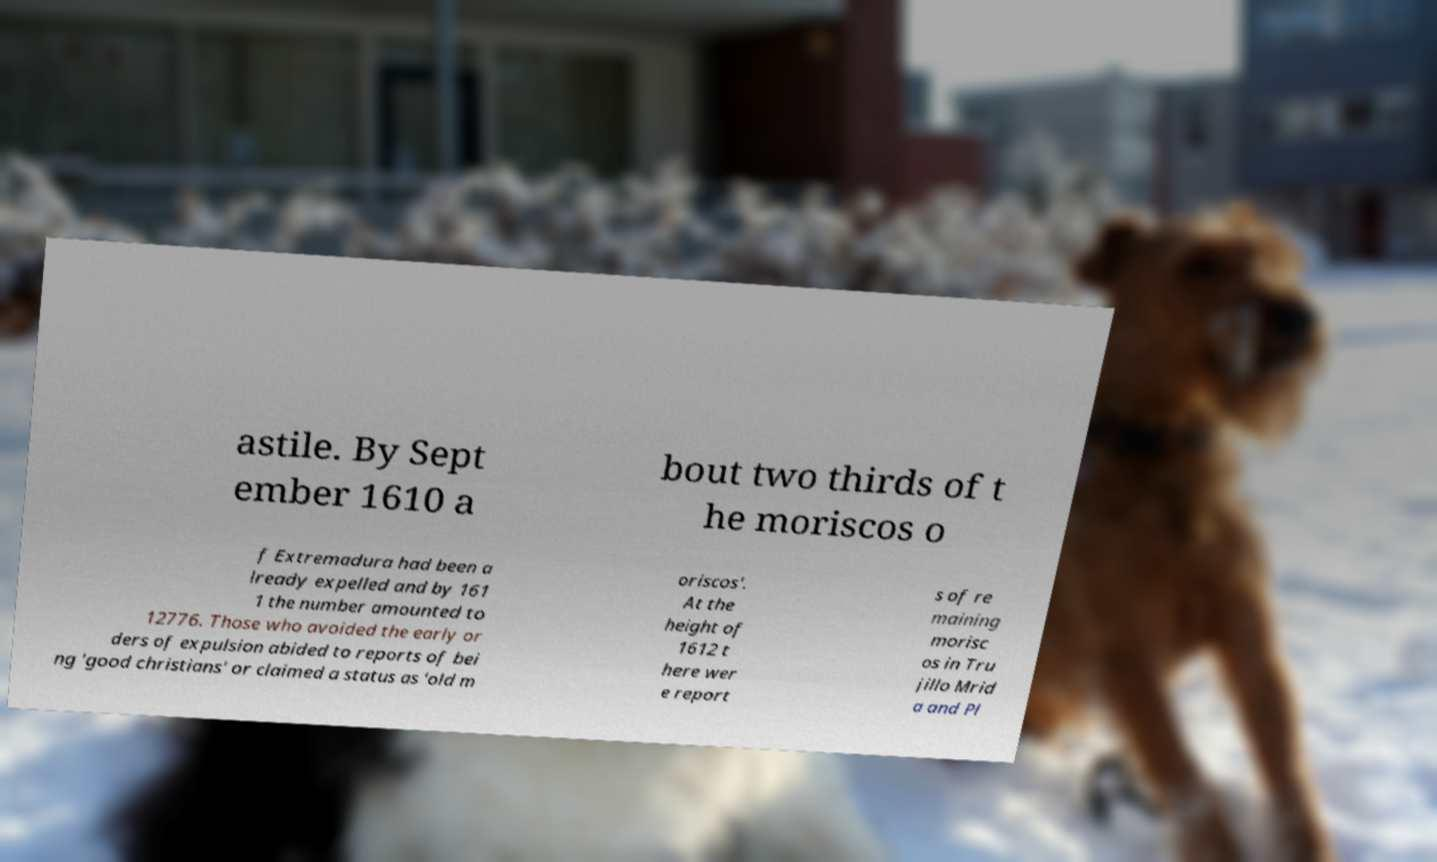Please read and relay the text visible in this image. What does it say? astile. By Sept ember 1610 a bout two thirds of t he moriscos o f Extremadura had been a lready expelled and by 161 1 the number amounted to 12776. Those who avoided the early or ders of expulsion abided to reports of bei ng 'good christians' or claimed a status as 'old m oriscos'. At the height of 1612 t here wer e report s of re maining morisc os in Tru jillo Mrid a and Pl 